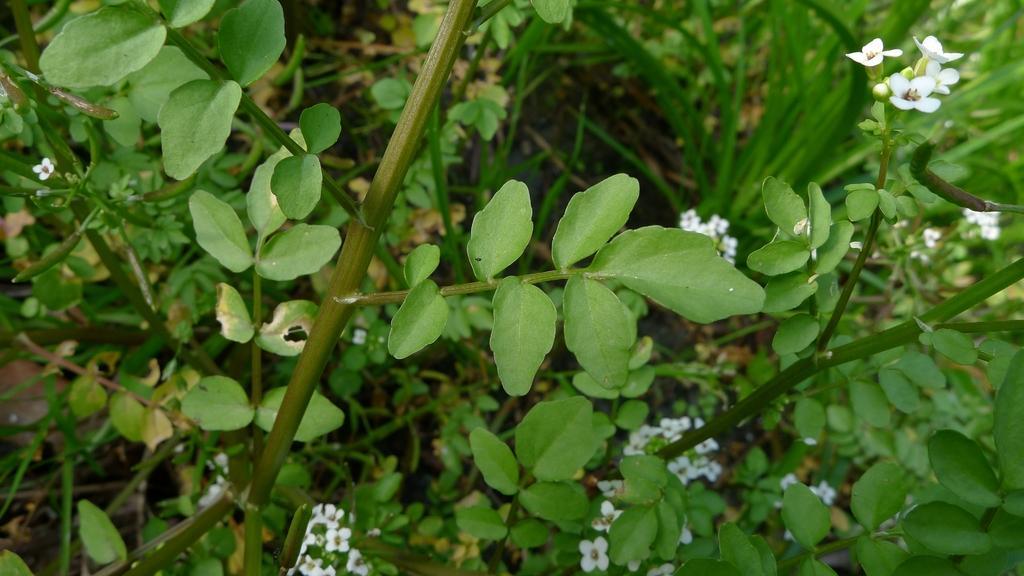Describe this image in one or two sentences. In this image I can see grass and flowering plants. This image is taken in a farm. 